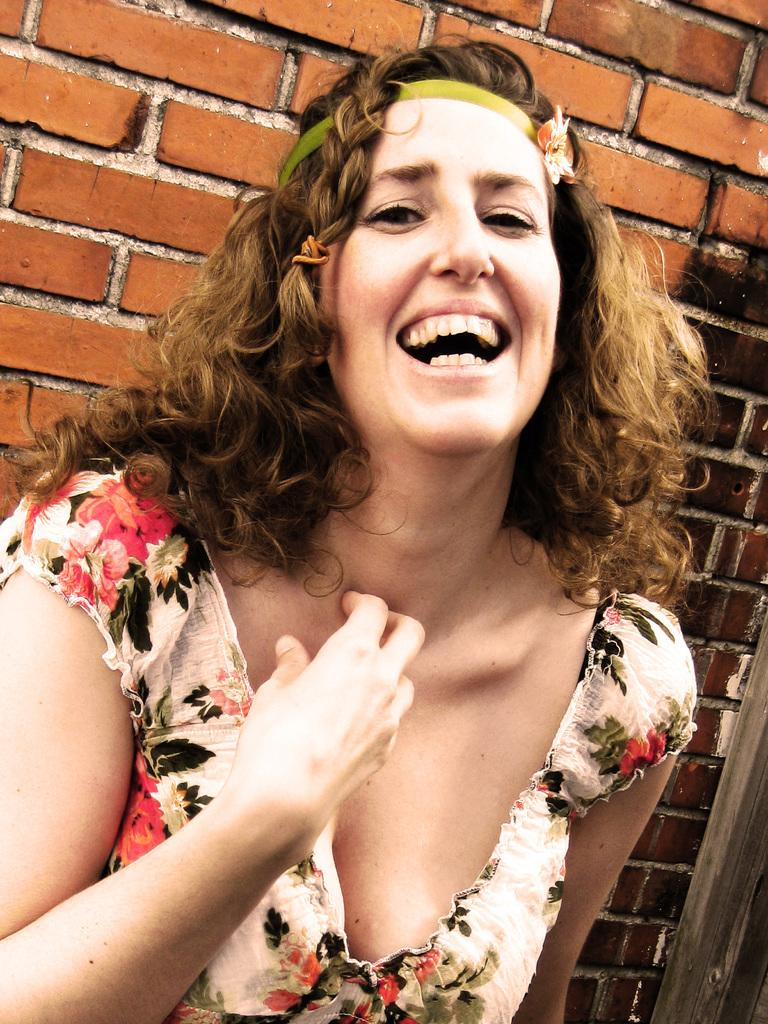Who is the main subject in the image? There is a woman in the center of the image. What can be seen in the background of the image? There is a wall in the background of the image. What type of noise can be heard coming from the kitten in the image? There is no kitten present in the image, so it is not possible to determine what noise might be heard. 